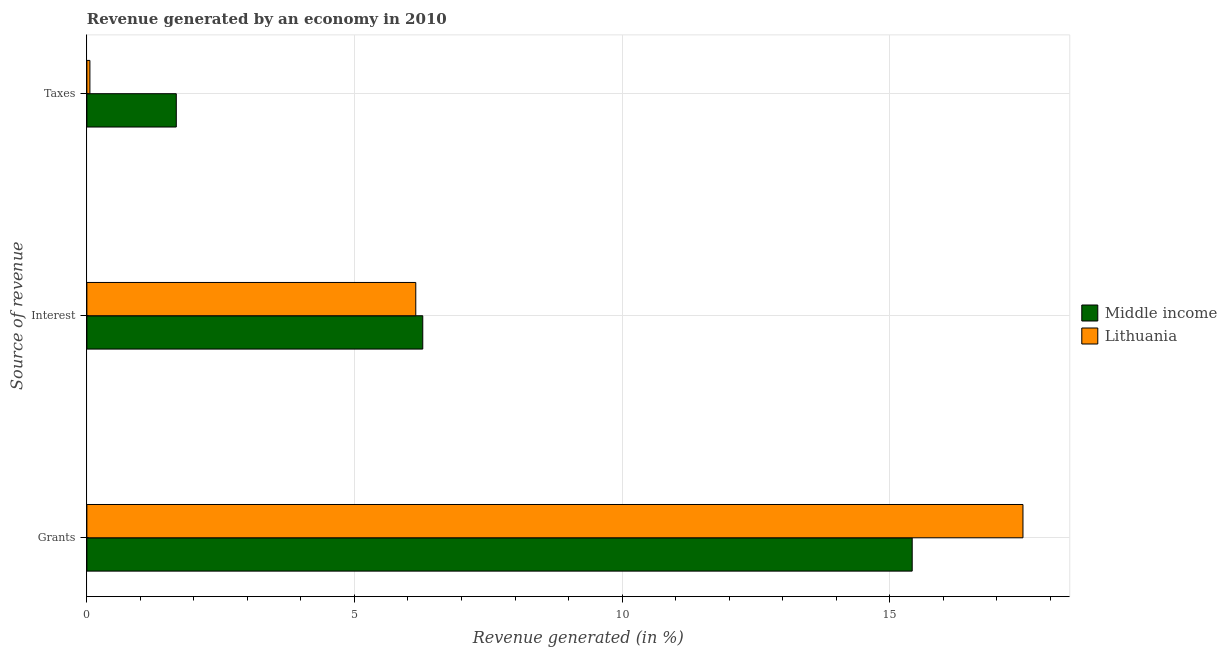Are the number of bars per tick equal to the number of legend labels?
Provide a succinct answer. Yes. Are the number of bars on each tick of the Y-axis equal?
Make the answer very short. Yes. What is the label of the 3rd group of bars from the top?
Offer a terse response. Grants. What is the percentage of revenue generated by grants in Lithuania?
Offer a terse response. 17.49. Across all countries, what is the maximum percentage of revenue generated by grants?
Your response must be concise. 17.49. Across all countries, what is the minimum percentage of revenue generated by grants?
Provide a short and direct response. 15.42. In which country was the percentage of revenue generated by taxes maximum?
Your answer should be compact. Middle income. In which country was the percentage of revenue generated by taxes minimum?
Your answer should be very brief. Lithuania. What is the total percentage of revenue generated by grants in the graph?
Offer a terse response. 32.91. What is the difference between the percentage of revenue generated by interest in Lithuania and that in Middle income?
Your answer should be very brief. -0.13. What is the difference between the percentage of revenue generated by grants in Lithuania and the percentage of revenue generated by taxes in Middle income?
Your response must be concise. 15.82. What is the average percentage of revenue generated by taxes per country?
Offer a very short reply. 0.86. What is the difference between the percentage of revenue generated by interest and percentage of revenue generated by taxes in Middle income?
Provide a short and direct response. 4.61. What is the ratio of the percentage of revenue generated by grants in Lithuania to that in Middle income?
Keep it short and to the point. 1.13. Is the percentage of revenue generated by interest in Middle income less than that in Lithuania?
Your answer should be very brief. No. Is the difference between the percentage of revenue generated by grants in Lithuania and Middle income greater than the difference between the percentage of revenue generated by taxes in Lithuania and Middle income?
Make the answer very short. Yes. What is the difference between the highest and the second highest percentage of revenue generated by interest?
Ensure brevity in your answer.  0.13. What is the difference between the highest and the lowest percentage of revenue generated by taxes?
Give a very brief answer. 1.61. In how many countries, is the percentage of revenue generated by grants greater than the average percentage of revenue generated by grants taken over all countries?
Make the answer very short. 1. Is the sum of the percentage of revenue generated by interest in Lithuania and Middle income greater than the maximum percentage of revenue generated by grants across all countries?
Offer a terse response. No. What does the 1st bar from the top in Grants represents?
Your answer should be very brief. Lithuania. What does the 1st bar from the bottom in Grants represents?
Offer a terse response. Middle income. How many countries are there in the graph?
Provide a short and direct response. 2. What is the difference between two consecutive major ticks on the X-axis?
Keep it short and to the point. 5. Are the values on the major ticks of X-axis written in scientific E-notation?
Your answer should be very brief. No. Where does the legend appear in the graph?
Provide a succinct answer. Center right. What is the title of the graph?
Your response must be concise. Revenue generated by an economy in 2010. Does "Guatemala" appear as one of the legend labels in the graph?
Make the answer very short. No. What is the label or title of the X-axis?
Your response must be concise. Revenue generated (in %). What is the label or title of the Y-axis?
Give a very brief answer. Source of revenue. What is the Revenue generated (in %) in Middle income in Grants?
Provide a short and direct response. 15.42. What is the Revenue generated (in %) of Lithuania in Grants?
Your answer should be very brief. 17.49. What is the Revenue generated (in %) of Middle income in Interest?
Keep it short and to the point. 6.28. What is the Revenue generated (in %) in Lithuania in Interest?
Ensure brevity in your answer.  6.15. What is the Revenue generated (in %) of Middle income in Taxes?
Your answer should be very brief. 1.67. What is the Revenue generated (in %) in Lithuania in Taxes?
Give a very brief answer. 0.06. Across all Source of revenue, what is the maximum Revenue generated (in %) in Middle income?
Keep it short and to the point. 15.42. Across all Source of revenue, what is the maximum Revenue generated (in %) in Lithuania?
Your answer should be compact. 17.49. Across all Source of revenue, what is the minimum Revenue generated (in %) in Middle income?
Ensure brevity in your answer.  1.67. Across all Source of revenue, what is the minimum Revenue generated (in %) of Lithuania?
Offer a very short reply. 0.06. What is the total Revenue generated (in %) of Middle income in the graph?
Ensure brevity in your answer.  23.37. What is the total Revenue generated (in %) of Lithuania in the graph?
Give a very brief answer. 23.69. What is the difference between the Revenue generated (in %) in Middle income in Grants and that in Interest?
Provide a succinct answer. 9.15. What is the difference between the Revenue generated (in %) in Lithuania in Grants and that in Interest?
Provide a succinct answer. 11.35. What is the difference between the Revenue generated (in %) in Middle income in Grants and that in Taxes?
Make the answer very short. 13.75. What is the difference between the Revenue generated (in %) in Lithuania in Grants and that in Taxes?
Provide a succinct answer. 17.43. What is the difference between the Revenue generated (in %) in Middle income in Interest and that in Taxes?
Ensure brevity in your answer.  4.61. What is the difference between the Revenue generated (in %) in Lithuania in Interest and that in Taxes?
Ensure brevity in your answer.  6.09. What is the difference between the Revenue generated (in %) in Middle income in Grants and the Revenue generated (in %) in Lithuania in Interest?
Make the answer very short. 9.28. What is the difference between the Revenue generated (in %) in Middle income in Grants and the Revenue generated (in %) in Lithuania in Taxes?
Your answer should be compact. 15.36. What is the difference between the Revenue generated (in %) of Middle income in Interest and the Revenue generated (in %) of Lithuania in Taxes?
Offer a terse response. 6.22. What is the average Revenue generated (in %) of Middle income per Source of revenue?
Give a very brief answer. 7.79. What is the average Revenue generated (in %) of Lithuania per Source of revenue?
Give a very brief answer. 7.9. What is the difference between the Revenue generated (in %) of Middle income and Revenue generated (in %) of Lithuania in Grants?
Provide a succinct answer. -2.07. What is the difference between the Revenue generated (in %) in Middle income and Revenue generated (in %) in Lithuania in Interest?
Provide a short and direct response. 0.13. What is the difference between the Revenue generated (in %) in Middle income and Revenue generated (in %) in Lithuania in Taxes?
Provide a succinct answer. 1.61. What is the ratio of the Revenue generated (in %) in Middle income in Grants to that in Interest?
Provide a succinct answer. 2.46. What is the ratio of the Revenue generated (in %) in Lithuania in Grants to that in Interest?
Provide a succinct answer. 2.85. What is the ratio of the Revenue generated (in %) in Middle income in Grants to that in Taxes?
Your answer should be very brief. 9.23. What is the ratio of the Revenue generated (in %) of Lithuania in Grants to that in Taxes?
Offer a terse response. 308.6. What is the ratio of the Revenue generated (in %) in Middle income in Interest to that in Taxes?
Ensure brevity in your answer.  3.76. What is the ratio of the Revenue generated (in %) of Lithuania in Interest to that in Taxes?
Ensure brevity in your answer.  108.43. What is the difference between the highest and the second highest Revenue generated (in %) of Middle income?
Ensure brevity in your answer.  9.15. What is the difference between the highest and the second highest Revenue generated (in %) of Lithuania?
Ensure brevity in your answer.  11.35. What is the difference between the highest and the lowest Revenue generated (in %) of Middle income?
Offer a terse response. 13.75. What is the difference between the highest and the lowest Revenue generated (in %) of Lithuania?
Keep it short and to the point. 17.43. 